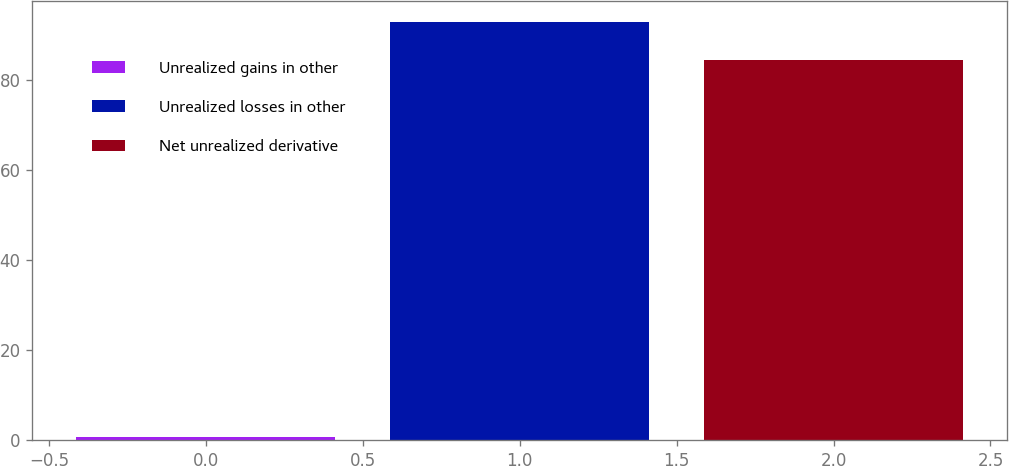Convert chart. <chart><loc_0><loc_0><loc_500><loc_500><bar_chart><fcel>Unrealized gains in other<fcel>Unrealized losses in other<fcel>Net unrealized derivative<nl><fcel>0.7<fcel>93.06<fcel>84.6<nl></chart> 